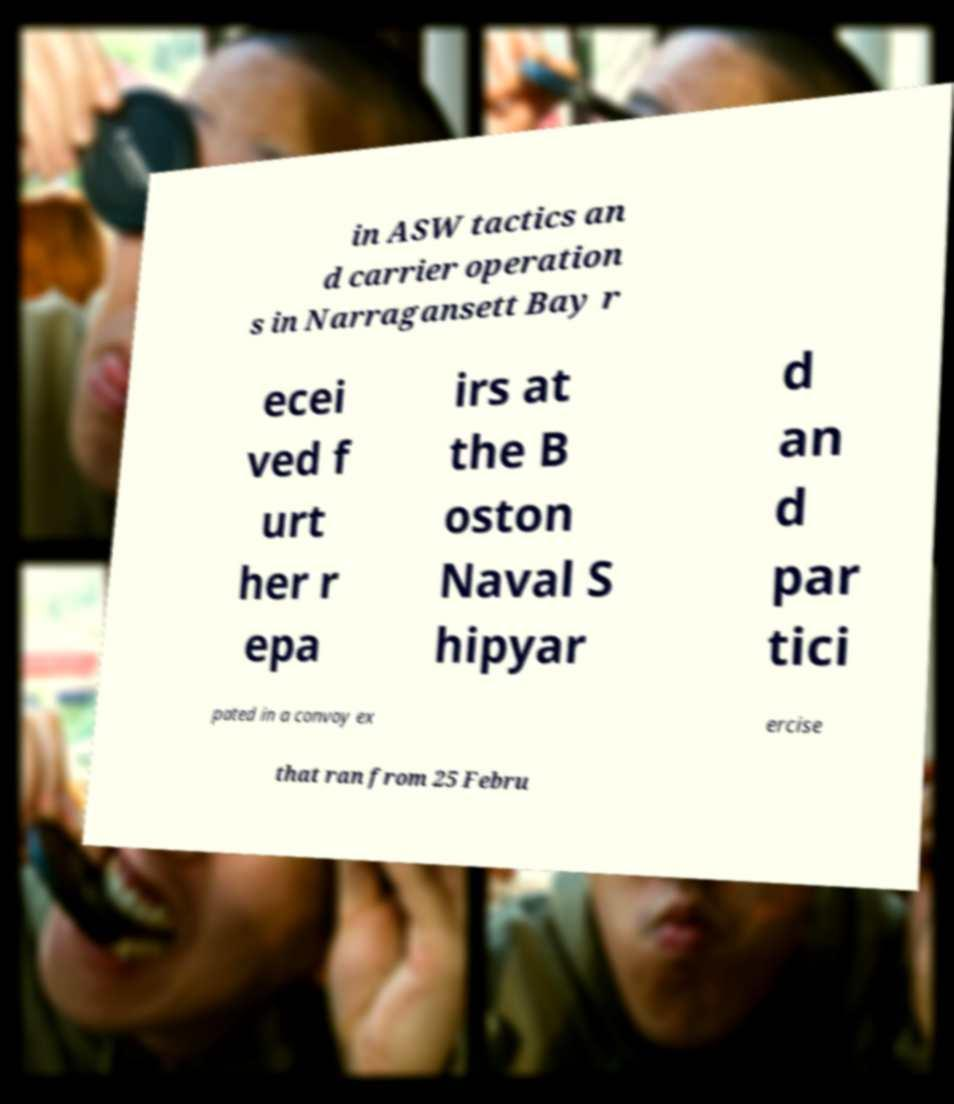Can you accurately transcribe the text from the provided image for me? in ASW tactics an d carrier operation s in Narragansett Bay r ecei ved f urt her r epa irs at the B oston Naval S hipyar d an d par tici pated in a convoy ex ercise that ran from 25 Febru 